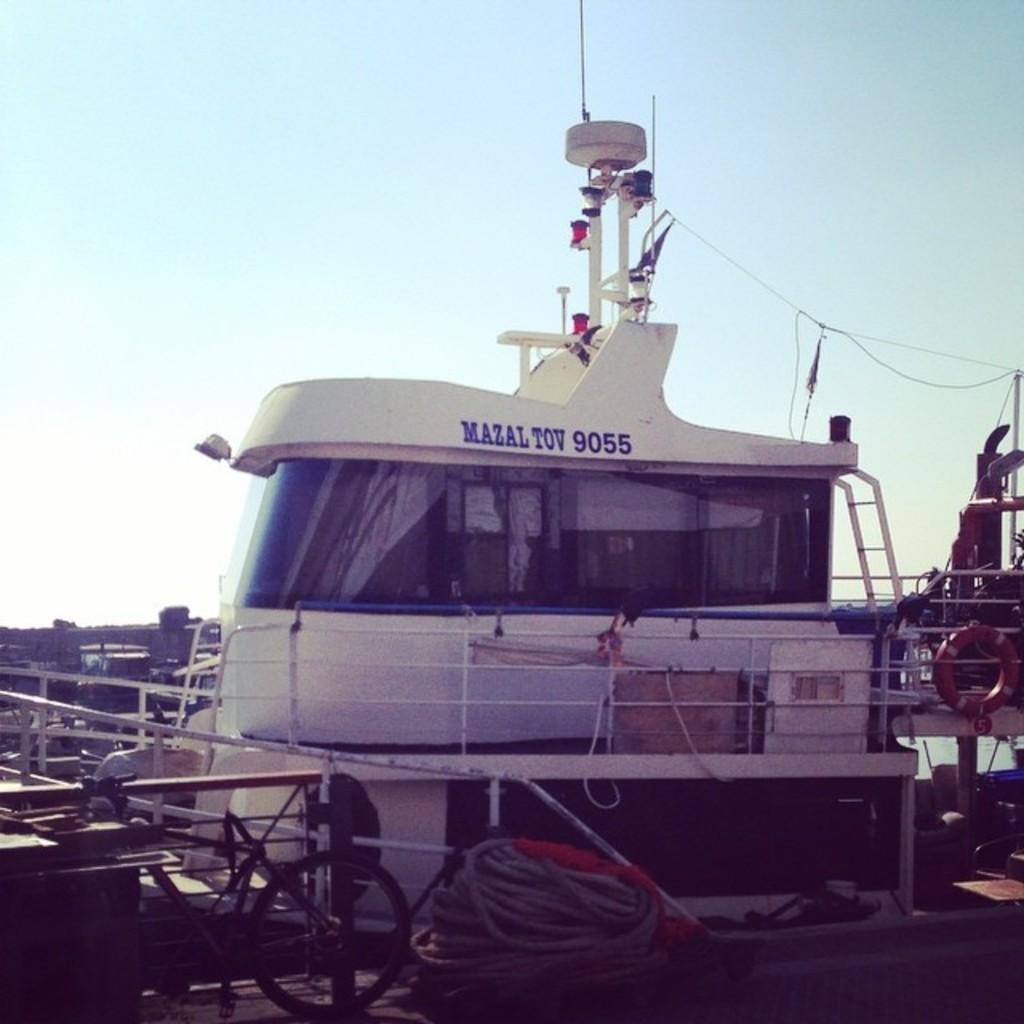What is the main subject of the image? The main subject of the image is a ship. What color is the ship? The ship is white in color. What can be seen in the background of the image? The background of the image includes the sky. What colors are visible in the sky? The sky is blue and white in color. What type of riddle can be seen on the playground in the image? There is no playground or riddle present in the image; it features a white ship with a blue and white sky in the background. Can you tell me how many basketballs are visible in the image? There are no basketballs present in the image. 